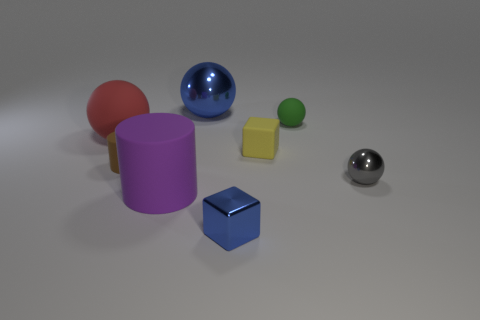Add 1 purple things. How many objects exist? 9 Subtract all purple balls. Subtract all blue cylinders. How many balls are left? 4 Subtract all cylinders. How many objects are left? 6 Add 1 green matte balls. How many green matte balls exist? 2 Subtract 0 red cylinders. How many objects are left? 8 Subtract all small gray things. Subtract all tiny blue metallic objects. How many objects are left? 6 Add 6 small matte cylinders. How many small matte cylinders are left? 7 